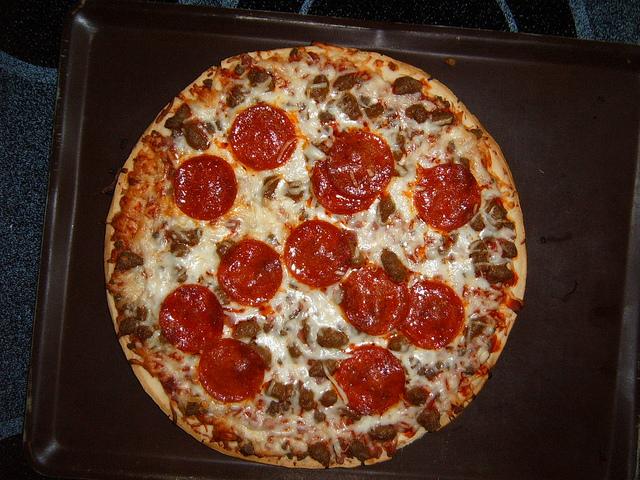What temperature was the pizza baked at?
Be succinct. 400. Is this a deep dish pizza?
Short answer required. No. What toppings are on the pizza?
Write a very short answer. Pepperoni and sausage. 